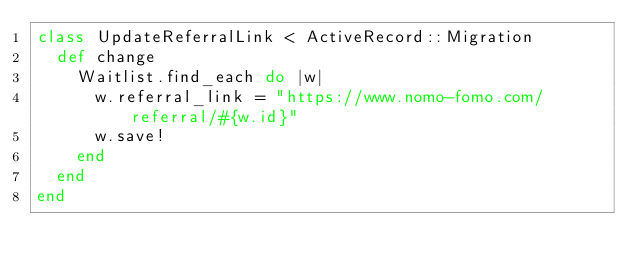Convert code to text. <code><loc_0><loc_0><loc_500><loc_500><_Ruby_>class UpdateReferralLink < ActiveRecord::Migration
  def change
    Waitlist.find_each do |w|
      w.referral_link = "https://www.nomo-fomo.com/referral/#{w.id}"
      w.save!
    end
  end
end
</code> 